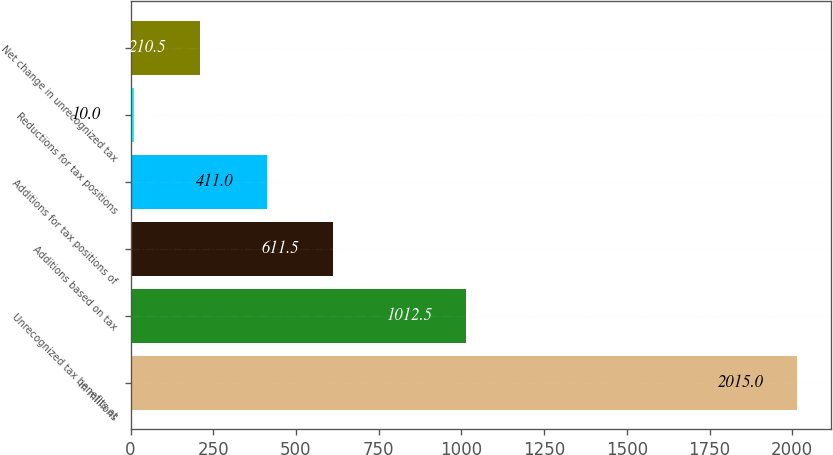<chart> <loc_0><loc_0><loc_500><loc_500><bar_chart><fcel>in millions<fcel>Unrecognized tax benefits at<fcel>Additions based on tax<fcel>Additions for tax positions of<fcel>Reductions for tax positions<fcel>Net change in unrecognized tax<nl><fcel>2015<fcel>1012.5<fcel>611.5<fcel>411<fcel>10<fcel>210.5<nl></chart> 